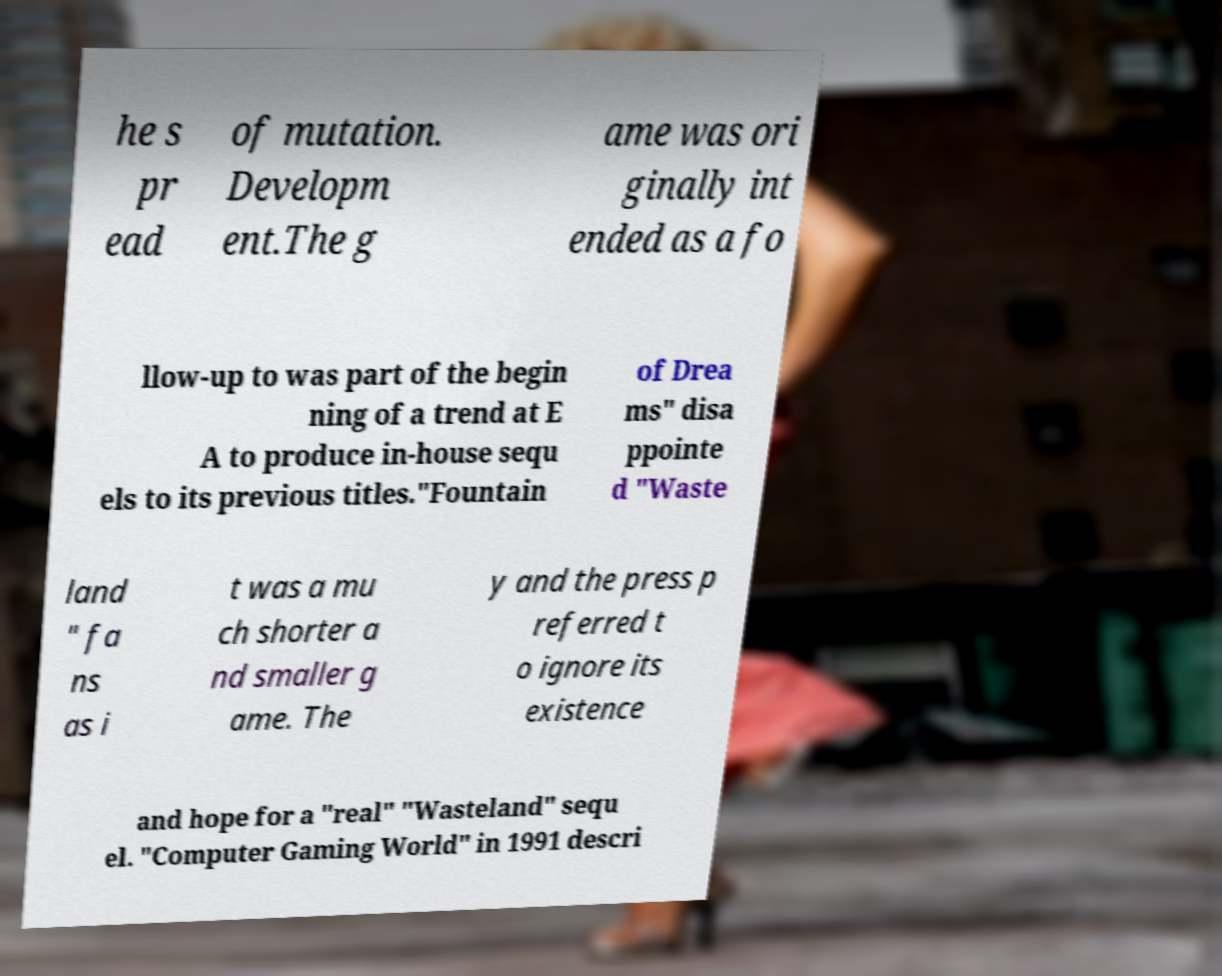Could you assist in decoding the text presented in this image and type it out clearly? he s pr ead of mutation. Developm ent.The g ame was ori ginally int ended as a fo llow-up to was part of the begin ning of a trend at E A to produce in-house sequ els to its previous titles."Fountain of Drea ms" disa ppointe d "Waste land " fa ns as i t was a mu ch shorter a nd smaller g ame. The y and the press p referred t o ignore its existence and hope for a "real" "Wasteland" sequ el. "Computer Gaming World" in 1991 descri 